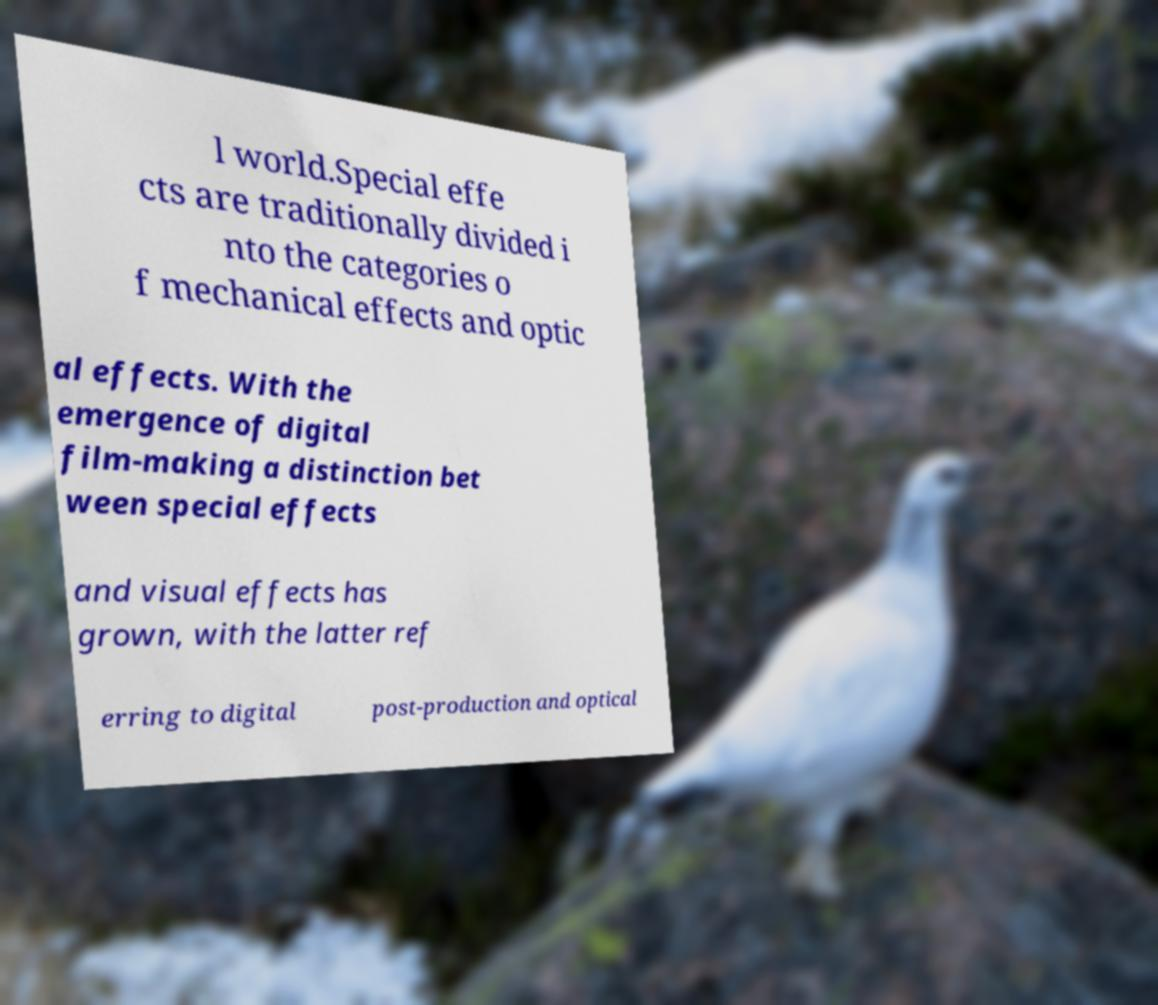Could you assist in decoding the text presented in this image and type it out clearly? l world.Special effe cts are traditionally divided i nto the categories o f mechanical effects and optic al effects. With the emergence of digital film-making a distinction bet ween special effects and visual effects has grown, with the latter ref erring to digital post-production and optical 